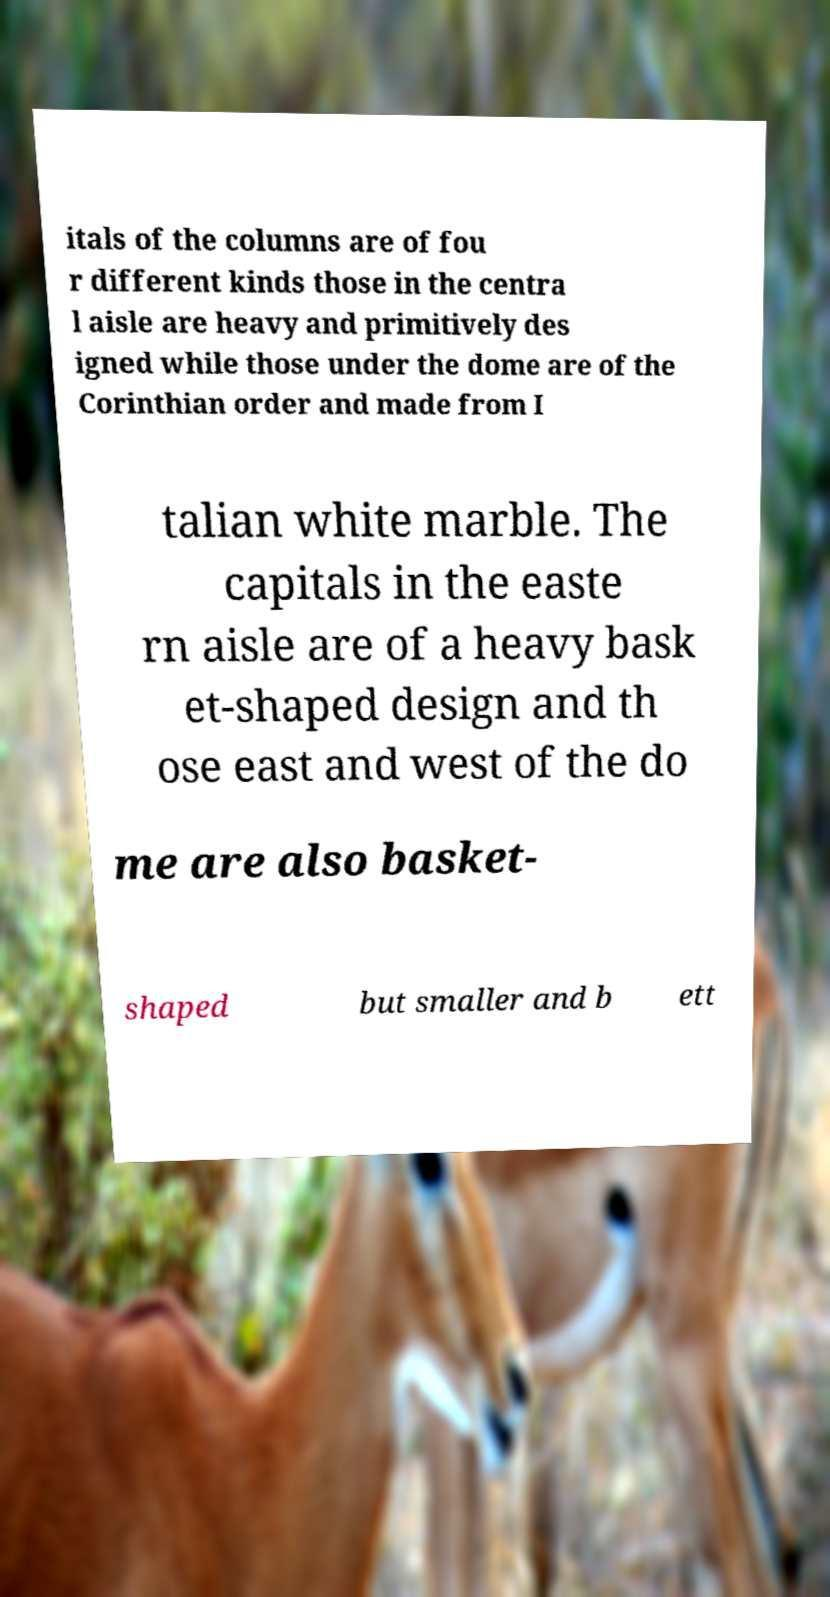For documentation purposes, I need the text within this image transcribed. Could you provide that? itals of the columns are of fou r different kinds those in the centra l aisle are heavy and primitively des igned while those under the dome are of the Corinthian order and made from I talian white marble. The capitals in the easte rn aisle are of a heavy bask et-shaped design and th ose east and west of the do me are also basket- shaped but smaller and b ett 